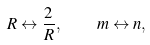Convert formula to latex. <formula><loc_0><loc_0><loc_500><loc_500>R \leftrightarrow \frac { 2 } { R } , \quad m \leftrightarrow n ,</formula> 